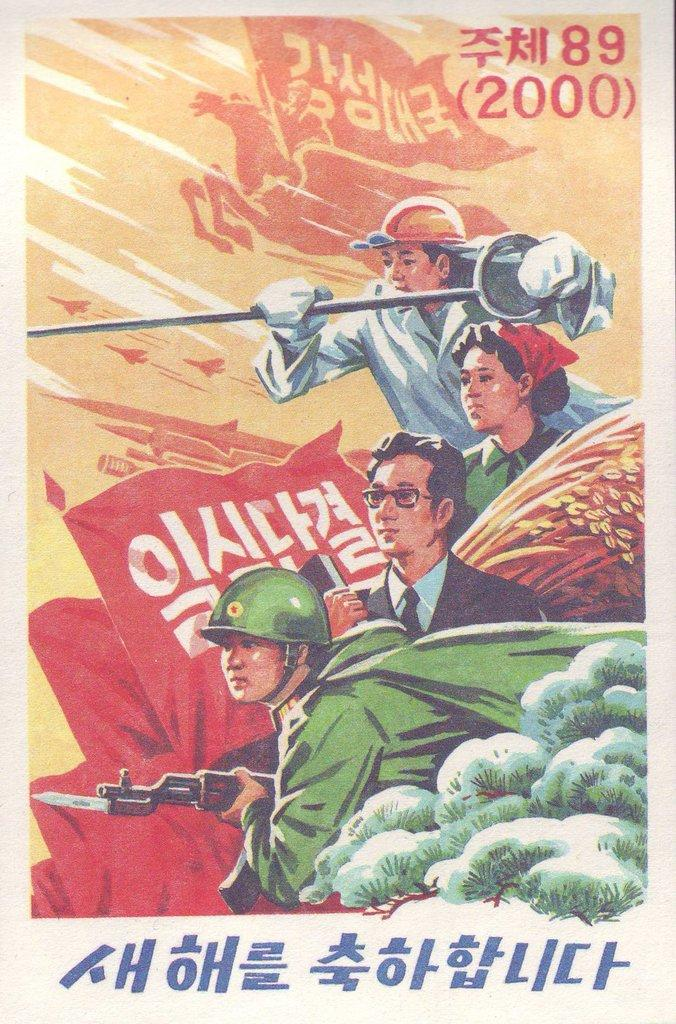<image>
Provide a brief description of the given image. Three men and and a woman all from different jobs but in the same year of 2000. 